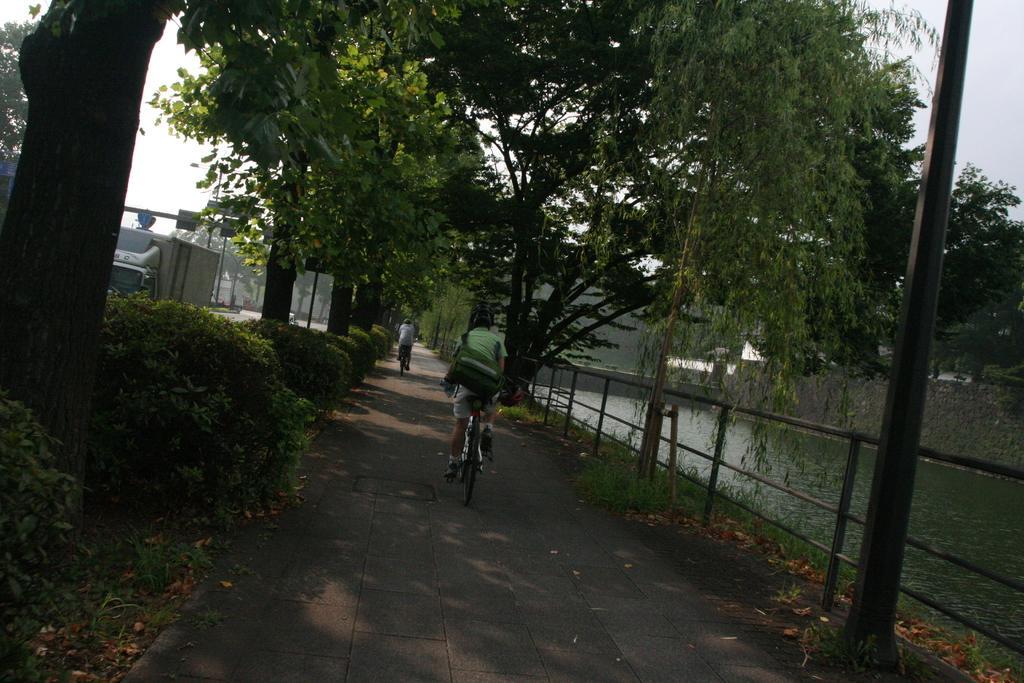How would you summarize this image in a sentence or two? In this image I see 2 persons who are on the cycles and I see the path and I see the bushes and trees. I can also see pole over here and I see the fencing. In the background I see the water and I see few more trees over here and I see the sky. 